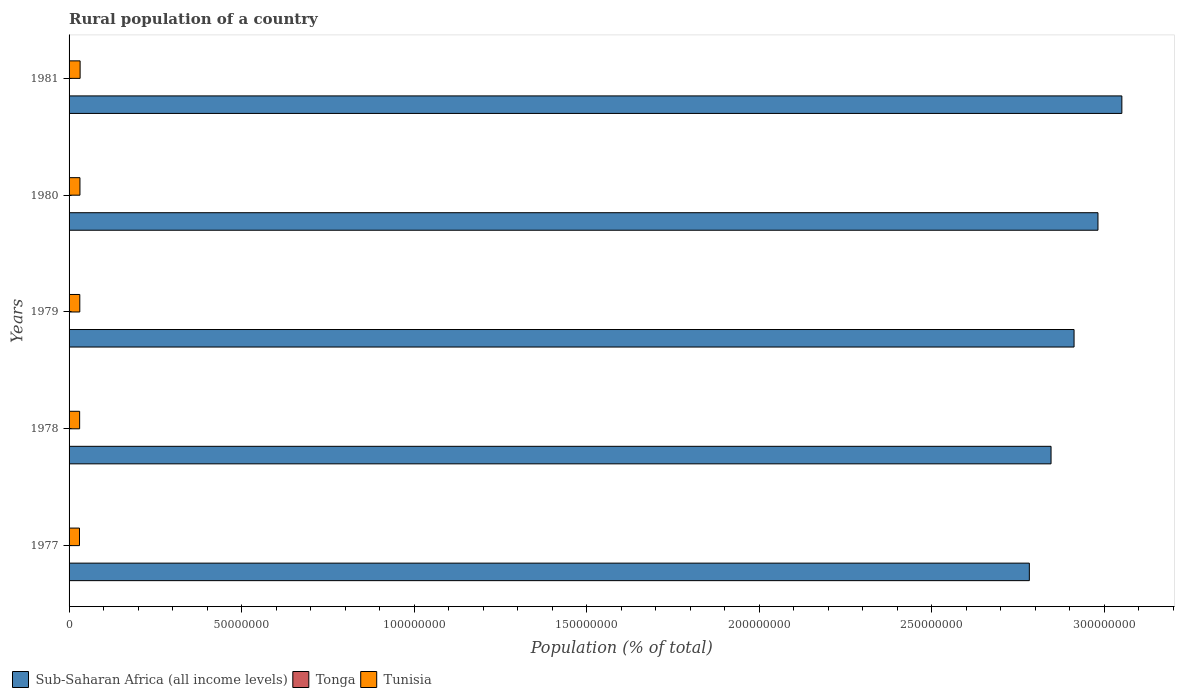How many different coloured bars are there?
Your answer should be compact. 3. Are the number of bars per tick equal to the number of legend labels?
Ensure brevity in your answer.  Yes. Are the number of bars on each tick of the Y-axis equal?
Give a very brief answer. Yes. What is the rural population in Tonga in 1981?
Provide a succinct answer. 7.35e+04. Across all years, what is the maximum rural population in Tunisia?
Provide a succinct answer. 3.20e+06. Across all years, what is the minimum rural population in Tunisia?
Provide a succinct answer. 3.02e+06. In which year was the rural population in Tonga maximum?
Your answer should be very brief. 1981. In which year was the rural population in Sub-Saharan Africa (all income levels) minimum?
Provide a short and direct response. 1977. What is the total rural population in Sub-Saharan Africa (all income levels) in the graph?
Provide a succinct answer. 1.46e+09. What is the difference between the rural population in Tunisia in 1979 and that in 1981?
Provide a succinct answer. -9.17e+04. What is the difference between the rural population in Tonga in 1979 and the rural population in Tunisia in 1978?
Offer a very short reply. -2.99e+06. What is the average rural population in Tonga per year?
Keep it short and to the point. 7.28e+04. In the year 1981, what is the difference between the rural population in Sub-Saharan Africa (all income levels) and rural population in Tonga?
Ensure brevity in your answer.  3.05e+08. In how many years, is the rural population in Sub-Saharan Africa (all income levels) greater than 240000000 %?
Ensure brevity in your answer.  5. What is the ratio of the rural population in Sub-Saharan Africa (all income levels) in 1978 to that in 1980?
Ensure brevity in your answer.  0.95. What is the difference between the highest and the second highest rural population in Sub-Saharan Africa (all income levels)?
Offer a very short reply. 6.92e+06. What is the difference between the highest and the lowest rural population in Tonga?
Keep it short and to the point. 1697. In how many years, is the rural population in Tonga greater than the average rural population in Tonga taken over all years?
Ensure brevity in your answer.  3. What does the 1st bar from the top in 1981 represents?
Offer a very short reply. Tunisia. What does the 2nd bar from the bottom in 1980 represents?
Offer a very short reply. Tonga. Where does the legend appear in the graph?
Keep it short and to the point. Bottom left. How many legend labels are there?
Give a very brief answer. 3. What is the title of the graph?
Offer a terse response. Rural population of a country. Does "Timor-Leste" appear as one of the legend labels in the graph?
Your answer should be compact. No. What is the label or title of the X-axis?
Provide a short and direct response. Population (% of total). What is the Population (% of total) of Sub-Saharan Africa (all income levels) in 1977?
Offer a terse response. 2.78e+08. What is the Population (% of total) in Tonga in 1977?
Offer a terse response. 7.18e+04. What is the Population (% of total) of Tunisia in 1977?
Provide a succinct answer. 3.02e+06. What is the Population (% of total) in Sub-Saharan Africa (all income levels) in 1978?
Give a very brief answer. 2.85e+08. What is the Population (% of total) of Tonga in 1978?
Your answer should be very brief. 7.24e+04. What is the Population (% of total) in Tunisia in 1978?
Your answer should be very brief. 3.06e+06. What is the Population (% of total) of Sub-Saharan Africa (all income levels) in 1979?
Offer a very short reply. 2.91e+08. What is the Population (% of total) of Tonga in 1979?
Offer a very short reply. 7.30e+04. What is the Population (% of total) of Tunisia in 1979?
Ensure brevity in your answer.  3.11e+06. What is the Population (% of total) of Sub-Saharan Africa (all income levels) in 1980?
Offer a very short reply. 2.98e+08. What is the Population (% of total) in Tonga in 1980?
Keep it short and to the point. 7.33e+04. What is the Population (% of total) of Tunisia in 1980?
Make the answer very short. 3.16e+06. What is the Population (% of total) of Sub-Saharan Africa (all income levels) in 1981?
Provide a succinct answer. 3.05e+08. What is the Population (% of total) of Tonga in 1981?
Your response must be concise. 7.35e+04. What is the Population (% of total) in Tunisia in 1981?
Keep it short and to the point. 3.20e+06. Across all years, what is the maximum Population (% of total) in Sub-Saharan Africa (all income levels)?
Your answer should be compact. 3.05e+08. Across all years, what is the maximum Population (% of total) of Tonga?
Give a very brief answer. 7.35e+04. Across all years, what is the maximum Population (% of total) of Tunisia?
Make the answer very short. 3.20e+06. Across all years, what is the minimum Population (% of total) in Sub-Saharan Africa (all income levels)?
Ensure brevity in your answer.  2.78e+08. Across all years, what is the minimum Population (% of total) of Tonga?
Your answer should be very brief. 7.18e+04. Across all years, what is the minimum Population (% of total) in Tunisia?
Keep it short and to the point. 3.02e+06. What is the total Population (% of total) in Sub-Saharan Africa (all income levels) in the graph?
Give a very brief answer. 1.46e+09. What is the total Population (% of total) of Tonga in the graph?
Offer a very short reply. 3.64e+05. What is the total Population (% of total) in Tunisia in the graph?
Keep it short and to the point. 1.55e+07. What is the difference between the Population (% of total) in Sub-Saharan Africa (all income levels) in 1977 and that in 1978?
Your response must be concise. -6.29e+06. What is the difference between the Population (% of total) in Tonga in 1977 and that in 1978?
Offer a very short reply. -649. What is the difference between the Population (% of total) in Tunisia in 1977 and that in 1978?
Give a very brief answer. -4.58e+04. What is the difference between the Population (% of total) of Sub-Saharan Africa (all income levels) in 1977 and that in 1979?
Offer a terse response. -1.30e+07. What is the difference between the Population (% of total) of Tonga in 1977 and that in 1979?
Provide a short and direct response. -1194. What is the difference between the Population (% of total) of Tunisia in 1977 and that in 1979?
Offer a very short reply. -9.28e+04. What is the difference between the Population (% of total) of Sub-Saharan Africa (all income levels) in 1977 and that in 1980?
Give a very brief answer. -1.99e+07. What is the difference between the Population (% of total) in Tonga in 1977 and that in 1980?
Give a very brief answer. -1550. What is the difference between the Population (% of total) in Tunisia in 1977 and that in 1980?
Offer a very short reply. -1.39e+05. What is the difference between the Population (% of total) of Sub-Saharan Africa (all income levels) in 1977 and that in 1981?
Offer a very short reply. -2.68e+07. What is the difference between the Population (% of total) in Tonga in 1977 and that in 1981?
Ensure brevity in your answer.  -1697. What is the difference between the Population (% of total) of Tunisia in 1977 and that in 1981?
Offer a very short reply. -1.85e+05. What is the difference between the Population (% of total) of Sub-Saharan Africa (all income levels) in 1978 and that in 1979?
Your answer should be very brief. -6.67e+06. What is the difference between the Population (% of total) in Tonga in 1978 and that in 1979?
Your answer should be compact. -545. What is the difference between the Population (% of total) of Tunisia in 1978 and that in 1979?
Your answer should be compact. -4.70e+04. What is the difference between the Population (% of total) of Sub-Saharan Africa (all income levels) in 1978 and that in 1980?
Your answer should be compact. -1.36e+07. What is the difference between the Population (% of total) of Tonga in 1978 and that in 1980?
Offer a very short reply. -901. What is the difference between the Population (% of total) in Tunisia in 1978 and that in 1980?
Your response must be concise. -9.31e+04. What is the difference between the Population (% of total) in Sub-Saharan Africa (all income levels) in 1978 and that in 1981?
Give a very brief answer. -2.05e+07. What is the difference between the Population (% of total) of Tonga in 1978 and that in 1981?
Provide a short and direct response. -1048. What is the difference between the Population (% of total) of Tunisia in 1978 and that in 1981?
Offer a terse response. -1.39e+05. What is the difference between the Population (% of total) of Sub-Saharan Africa (all income levels) in 1979 and that in 1980?
Your answer should be compact. -6.93e+06. What is the difference between the Population (% of total) of Tonga in 1979 and that in 1980?
Make the answer very short. -356. What is the difference between the Population (% of total) of Tunisia in 1979 and that in 1980?
Provide a succinct answer. -4.61e+04. What is the difference between the Population (% of total) in Sub-Saharan Africa (all income levels) in 1979 and that in 1981?
Offer a terse response. -1.39e+07. What is the difference between the Population (% of total) of Tonga in 1979 and that in 1981?
Offer a very short reply. -503. What is the difference between the Population (% of total) in Tunisia in 1979 and that in 1981?
Provide a short and direct response. -9.17e+04. What is the difference between the Population (% of total) of Sub-Saharan Africa (all income levels) in 1980 and that in 1981?
Make the answer very short. -6.92e+06. What is the difference between the Population (% of total) of Tonga in 1980 and that in 1981?
Your answer should be very brief. -147. What is the difference between the Population (% of total) in Tunisia in 1980 and that in 1981?
Your answer should be compact. -4.56e+04. What is the difference between the Population (% of total) of Sub-Saharan Africa (all income levels) in 1977 and the Population (% of total) of Tonga in 1978?
Your response must be concise. 2.78e+08. What is the difference between the Population (% of total) of Sub-Saharan Africa (all income levels) in 1977 and the Population (% of total) of Tunisia in 1978?
Give a very brief answer. 2.75e+08. What is the difference between the Population (% of total) of Tonga in 1977 and the Population (% of total) of Tunisia in 1978?
Your answer should be compact. -2.99e+06. What is the difference between the Population (% of total) of Sub-Saharan Africa (all income levels) in 1977 and the Population (% of total) of Tonga in 1979?
Your response must be concise. 2.78e+08. What is the difference between the Population (% of total) in Sub-Saharan Africa (all income levels) in 1977 and the Population (% of total) in Tunisia in 1979?
Give a very brief answer. 2.75e+08. What is the difference between the Population (% of total) of Tonga in 1977 and the Population (% of total) of Tunisia in 1979?
Your answer should be very brief. -3.04e+06. What is the difference between the Population (% of total) of Sub-Saharan Africa (all income levels) in 1977 and the Population (% of total) of Tonga in 1980?
Ensure brevity in your answer.  2.78e+08. What is the difference between the Population (% of total) of Sub-Saharan Africa (all income levels) in 1977 and the Population (% of total) of Tunisia in 1980?
Offer a terse response. 2.75e+08. What is the difference between the Population (% of total) in Tonga in 1977 and the Population (% of total) in Tunisia in 1980?
Give a very brief answer. -3.08e+06. What is the difference between the Population (% of total) of Sub-Saharan Africa (all income levels) in 1977 and the Population (% of total) of Tonga in 1981?
Your response must be concise. 2.78e+08. What is the difference between the Population (% of total) of Sub-Saharan Africa (all income levels) in 1977 and the Population (% of total) of Tunisia in 1981?
Offer a terse response. 2.75e+08. What is the difference between the Population (% of total) in Tonga in 1977 and the Population (% of total) in Tunisia in 1981?
Keep it short and to the point. -3.13e+06. What is the difference between the Population (% of total) of Sub-Saharan Africa (all income levels) in 1978 and the Population (% of total) of Tonga in 1979?
Keep it short and to the point. 2.85e+08. What is the difference between the Population (% of total) of Sub-Saharan Africa (all income levels) in 1978 and the Population (% of total) of Tunisia in 1979?
Offer a very short reply. 2.81e+08. What is the difference between the Population (% of total) of Tonga in 1978 and the Population (% of total) of Tunisia in 1979?
Offer a very short reply. -3.04e+06. What is the difference between the Population (% of total) of Sub-Saharan Africa (all income levels) in 1978 and the Population (% of total) of Tonga in 1980?
Ensure brevity in your answer.  2.85e+08. What is the difference between the Population (% of total) in Sub-Saharan Africa (all income levels) in 1978 and the Population (% of total) in Tunisia in 1980?
Provide a short and direct response. 2.81e+08. What is the difference between the Population (% of total) in Tonga in 1978 and the Population (% of total) in Tunisia in 1980?
Ensure brevity in your answer.  -3.08e+06. What is the difference between the Population (% of total) in Sub-Saharan Africa (all income levels) in 1978 and the Population (% of total) in Tonga in 1981?
Provide a short and direct response. 2.85e+08. What is the difference between the Population (% of total) in Sub-Saharan Africa (all income levels) in 1978 and the Population (% of total) in Tunisia in 1981?
Your answer should be very brief. 2.81e+08. What is the difference between the Population (% of total) in Tonga in 1978 and the Population (% of total) in Tunisia in 1981?
Make the answer very short. -3.13e+06. What is the difference between the Population (% of total) in Sub-Saharan Africa (all income levels) in 1979 and the Population (% of total) in Tonga in 1980?
Offer a very short reply. 2.91e+08. What is the difference between the Population (% of total) of Sub-Saharan Africa (all income levels) in 1979 and the Population (% of total) of Tunisia in 1980?
Your response must be concise. 2.88e+08. What is the difference between the Population (% of total) in Tonga in 1979 and the Population (% of total) in Tunisia in 1980?
Offer a very short reply. -3.08e+06. What is the difference between the Population (% of total) of Sub-Saharan Africa (all income levels) in 1979 and the Population (% of total) of Tonga in 1981?
Your response must be concise. 2.91e+08. What is the difference between the Population (% of total) of Sub-Saharan Africa (all income levels) in 1979 and the Population (% of total) of Tunisia in 1981?
Offer a terse response. 2.88e+08. What is the difference between the Population (% of total) in Tonga in 1979 and the Population (% of total) in Tunisia in 1981?
Offer a very short reply. -3.13e+06. What is the difference between the Population (% of total) of Sub-Saharan Africa (all income levels) in 1980 and the Population (% of total) of Tonga in 1981?
Give a very brief answer. 2.98e+08. What is the difference between the Population (% of total) of Sub-Saharan Africa (all income levels) in 1980 and the Population (% of total) of Tunisia in 1981?
Ensure brevity in your answer.  2.95e+08. What is the difference between the Population (% of total) of Tonga in 1980 and the Population (% of total) of Tunisia in 1981?
Keep it short and to the point. -3.13e+06. What is the average Population (% of total) of Sub-Saharan Africa (all income levels) per year?
Your response must be concise. 2.91e+08. What is the average Population (% of total) of Tonga per year?
Your response must be concise. 7.28e+04. What is the average Population (% of total) of Tunisia per year?
Provide a short and direct response. 3.11e+06. In the year 1977, what is the difference between the Population (% of total) of Sub-Saharan Africa (all income levels) and Population (% of total) of Tonga?
Your response must be concise. 2.78e+08. In the year 1977, what is the difference between the Population (% of total) of Sub-Saharan Africa (all income levels) and Population (% of total) of Tunisia?
Offer a terse response. 2.75e+08. In the year 1977, what is the difference between the Population (% of total) of Tonga and Population (% of total) of Tunisia?
Make the answer very short. -2.94e+06. In the year 1978, what is the difference between the Population (% of total) of Sub-Saharan Africa (all income levels) and Population (% of total) of Tonga?
Ensure brevity in your answer.  2.85e+08. In the year 1978, what is the difference between the Population (% of total) of Sub-Saharan Africa (all income levels) and Population (% of total) of Tunisia?
Give a very brief answer. 2.82e+08. In the year 1978, what is the difference between the Population (% of total) of Tonga and Population (% of total) of Tunisia?
Make the answer very short. -2.99e+06. In the year 1979, what is the difference between the Population (% of total) of Sub-Saharan Africa (all income levels) and Population (% of total) of Tonga?
Offer a terse response. 2.91e+08. In the year 1979, what is the difference between the Population (% of total) of Sub-Saharan Africa (all income levels) and Population (% of total) of Tunisia?
Offer a very short reply. 2.88e+08. In the year 1979, what is the difference between the Population (% of total) in Tonga and Population (% of total) in Tunisia?
Offer a very short reply. -3.04e+06. In the year 1980, what is the difference between the Population (% of total) of Sub-Saharan Africa (all income levels) and Population (% of total) of Tonga?
Give a very brief answer. 2.98e+08. In the year 1980, what is the difference between the Population (% of total) in Sub-Saharan Africa (all income levels) and Population (% of total) in Tunisia?
Keep it short and to the point. 2.95e+08. In the year 1980, what is the difference between the Population (% of total) of Tonga and Population (% of total) of Tunisia?
Keep it short and to the point. -3.08e+06. In the year 1981, what is the difference between the Population (% of total) of Sub-Saharan Africa (all income levels) and Population (% of total) of Tonga?
Ensure brevity in your answer.  3.05e+08. In the year 1981, what is the difference between the Population (% of total) of Sub-Saharan Africa (all income levels) and Population (% of total) of Tunisia?
Ensure brevity in your answer.  3.02e+08. In the year 1981, what is the difference between the Population (% of total) in Tonga and Population (% of total) in Tunisia?
Provide a short and direct response. -3.13e+06. What is the ratio of the Population (% of total) of Sub-Saharan Africa (all income levels) in 1977 to that in 1978?
Offer a terse response. 0.98. What is the ratio of the Population (% of total) in Sub-Saharan Africa (all income levels) in 1977 to that in 1979?
Make the answer very short. 0.96. What is the ratio of the Population (% of total) in Tonga in 1977 to that in 1979?
Provide a short and direct response. 0.98. What is the ratio of the Population (% of total) in Tunisia in 1977 to that in 1979?
Your answer should be very brief. 0.97. What is the ratio of the Population (% of total) of Tonga in 1977 to that in 1980?
Your response must be concise. 0.98. What is the ratio of the Population (% of total) of Tunisia in 1977 to that in 1980?
Your response must be concise. 0.96. What is the ratio of the Population (% of total) of Sub-Saharan Africa (all income levels) in 1977 to that in 1981?
Your response must be concise. 0.91. What is the ratio of the Population (% of total) of Tonga in 1977 to that in 1981?
Ensure brevity in your answer.  0.98. What is the ratio of the Population (% of total) in Tunisia in 1977 to that in 1981?
Offer a terse response. 0.94. What is the ratio of the Population (% of total) of Sub-Saharan Africa (all income levels) in 1978 to that in 1979?
Keep it short and to the point. 0.98. What is the ratio of the Population (% of total) in Tunisia in 1978 to that in 1979?
Your answer should be compact. 0.98. What is the ratio of the Population (% of total) of Sub-Saharan Africa (all income levels) in 1978 to that in 1980?
Your response must be concise. 0.95. What is the ratio of the Population (% of total) in Tunisia in 1978 to that in 1980?
Your answer should be very brief. 0.97. What is the ratio of the Population (% of total) of Sub-Saharan Africa (all income levels) in 1978 to that in 1981?
Ensure brevity in your answer.  0.93. What is the ratio of the Population (% of total) in Tonga in 1978 to that in 1981?
Your answer should be compact. 0.99. What is the ratio of the Population (% of total) in Tunisia in 1978 to that in 1981?
Offer a terse response. 0.96. What is the ratio of the Population (% of total) in Sub-Saharan Africa (all income levels) in 1979 to that in 1980?
Your response must be concise. 0.98. What is the ratio of the Population (% of total) of Tunisia in 1979 to that in 1980?
Offer a very short reply. 0.99. What is the ratio of the Population (% of total) of Sub-Saharan Africa (all income levels) in 1979 to that in 1981?
Provide a succinct answer. 0.95. What is the ratio of the Population (% of total) in Tunisia in 1979 to that in 1981?
Ensure brevity in your answer.  0.97. What is the ratio of the Population (% of total) of Sub-Saharan Africa (all income levels) in 1980 to that in 1981?
Make the answer very short. 0.98. What is the ratio of the Population (% of total) in Tonga in 1980 to that in 1981?
Give a very brief answer. 1. What is the ratio of the Population (% of total) of Tunisia in 1980 to that in 1981?
Ensure brevity in your answer.  0.99. What is the difference between the highest and the second highest Population (% of total) of Sub-Saharan Africa (all income levels)?
Make the answer very short. 6.92e+06. What is the difference between the highest and the second highest Population (% of total) in Tonga?
Ensure brevity in your answer.  147. What is the difference between the highest and the second highest Population (% of total) of Tunisia?
Make the answer very short. 4.56e+04. What is the difference between the highest and the lowest Population (% of total) of Sub-Saharan Africa (all income levels)?
Offer a very short reply. 2.68e+07. What is the difference between the highest and the lowest Population (% of total) of Tonga?
Provide a short and direct response. 1697. What is the difference between the highest and the lowest Population (% of total) in Tunisia?
Provide a succinct answer. 1.85e+05. 